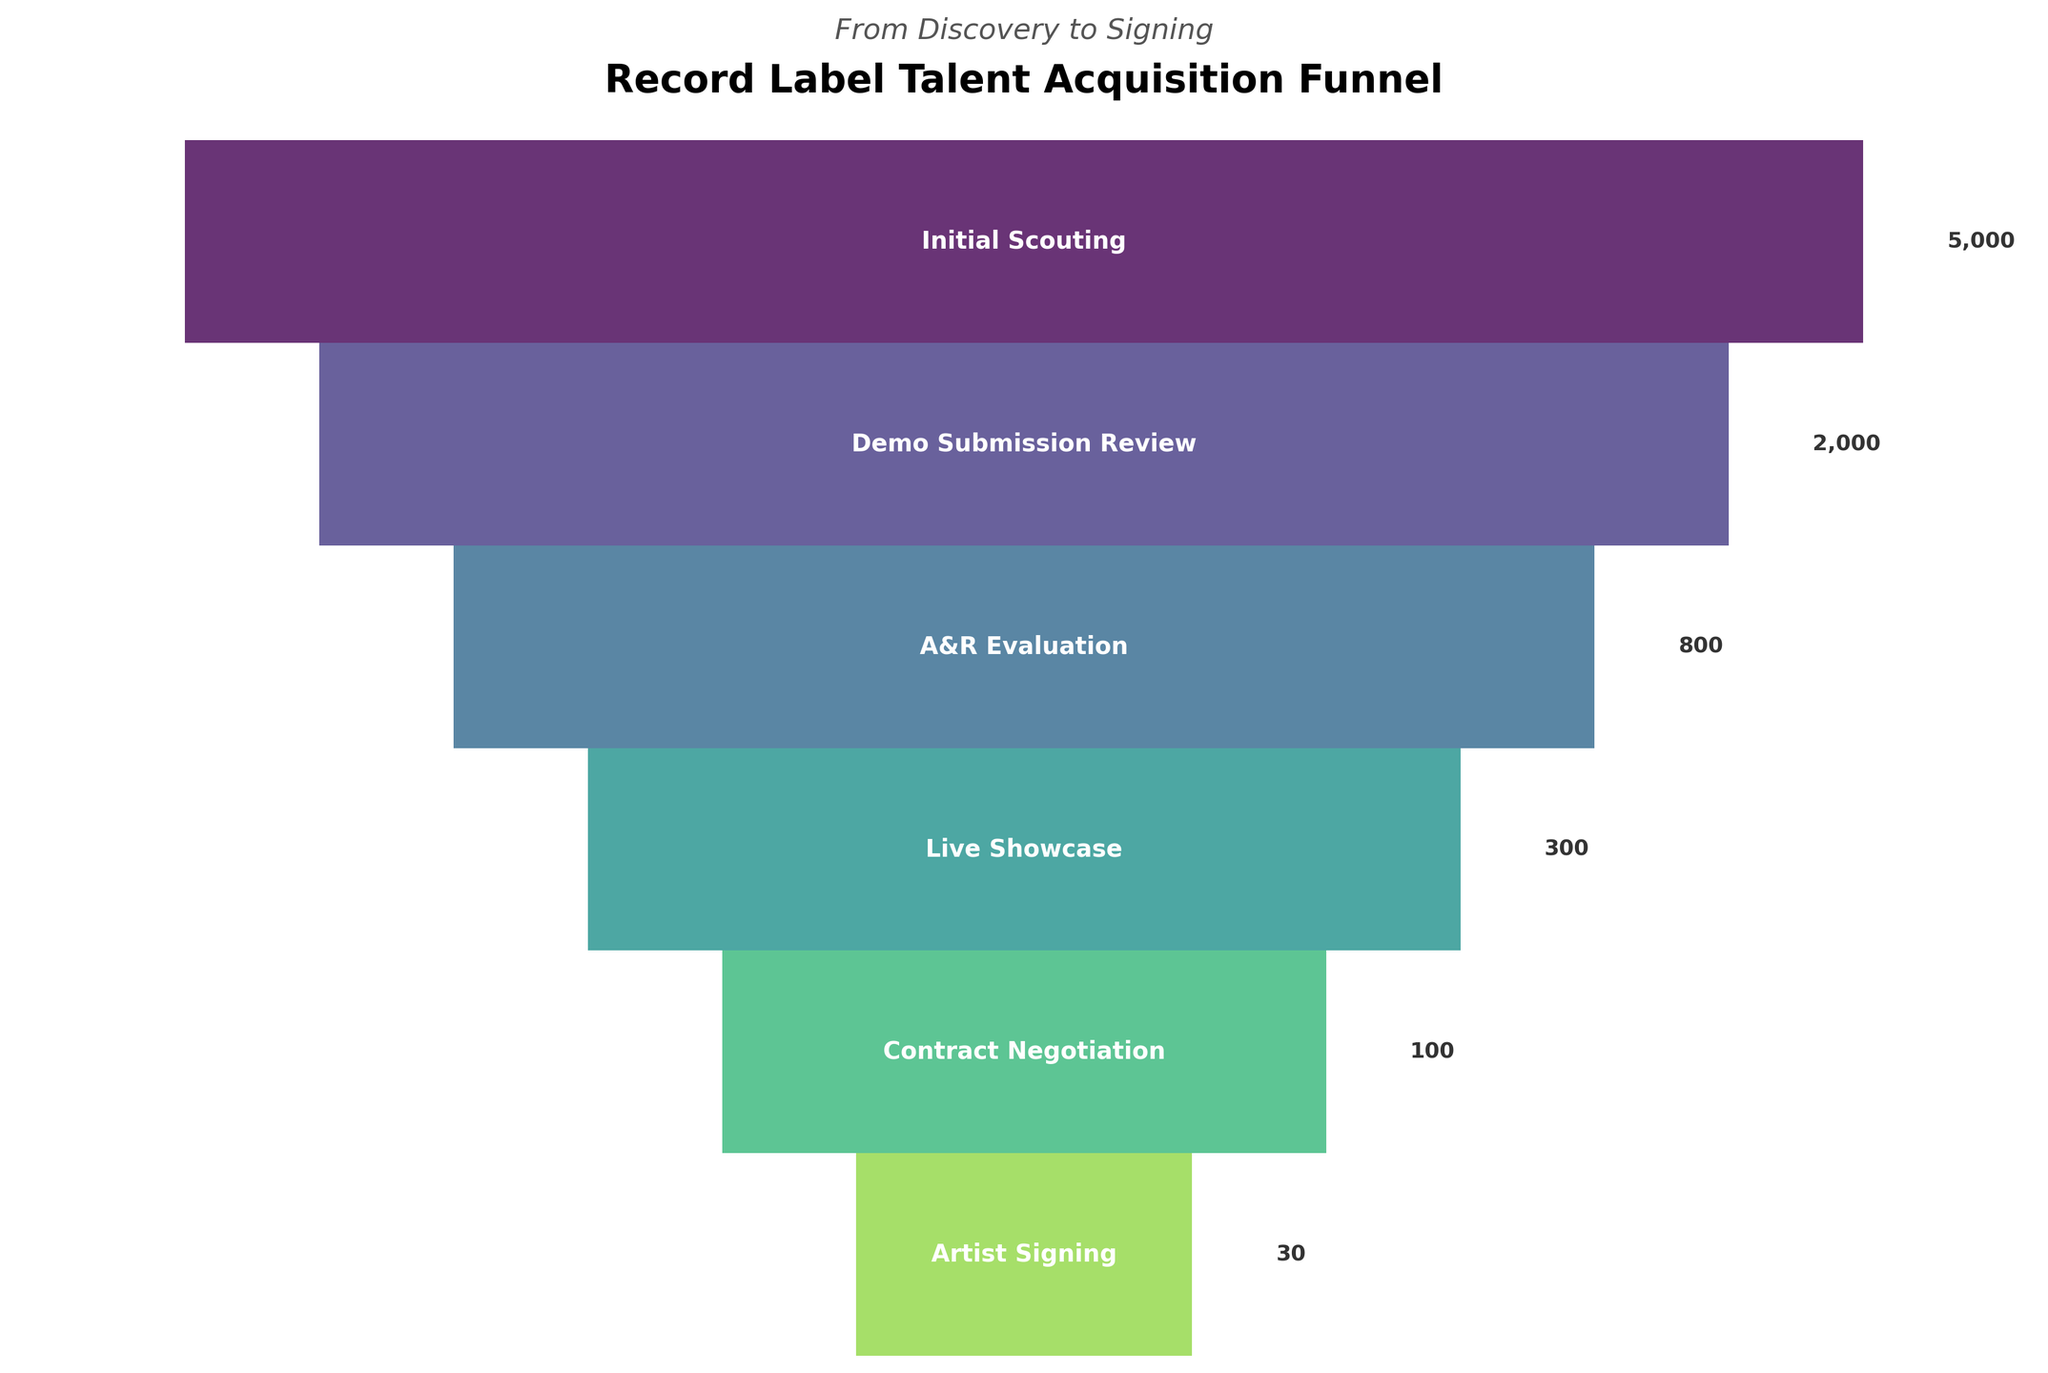What is the title of the funnel chart? The title is typically found at the top of the chart. It clearly states what the chart is about.
Answer: Record Label Talent Acquisition Funnel How many stages are there in the funnel before an artist is signed? By counting the number of distinct segments in the funnel, one can determine the total stages.
Answer: 6 What is the number of artists that reach the Demo Submission Review stage? The figure shows the funnel with labels for each stage and the corresponding number of artists.
Answer: 2000 Between which two stages is the largest drop-off in the number of artists seen? By observing the transitions between stages, look for the largest decrease in the number of artists. The largest difference is between "Initial Scouting" (5000) and "Demo Submission Review" (2000).
Answer: Initial Scouting and Demo Submission Review Which stage sees a reduction of artists to less than half of the preceding stage? By comparing the number of artists at each stage with the previous stage, the Demo Submission Review to A&R Evaluation (2000 to 800) and Live Showcase to Contract Negotiation (300 to 100) both see reductions of more than half.
Answer: Demo Submission Review to A&R Evaluation, Live Showcase to Contract Negotiation What is the overall percentage of artists signed compared to the initial scouting? Calculate the percentage by dividing the number of artists signed (30) by the initial scouting (5000) and multiplying by 100.
Answer: 0.6% How many artists make it through both the Live Showcase and Contract Negotiation stages but drop off before being signed? The number of artists at the Contract Negotiation stage minus the number of artists who are finally signed.
Answer: 70 What can be inferred about the label's selectiveness at each stage of the acquisition process? By observing the significant drop-offs at each stage, it can be inferred that the label is highly selective with increasingly stringent criteria as artists progress through each stage.
Answer: Highly selective How does the number of artists evaluated during A&R Evaluation compare to those in the Initial Scouting stage? Comparing the number “Initial Scouting” (5000) to “A&R Evaluation” (800), you can see the relation between them.
Answer: Less If the contract negotiation stage needed to double its number of artists, what would be the new number? Double the current number of 100.
Answer: 200 